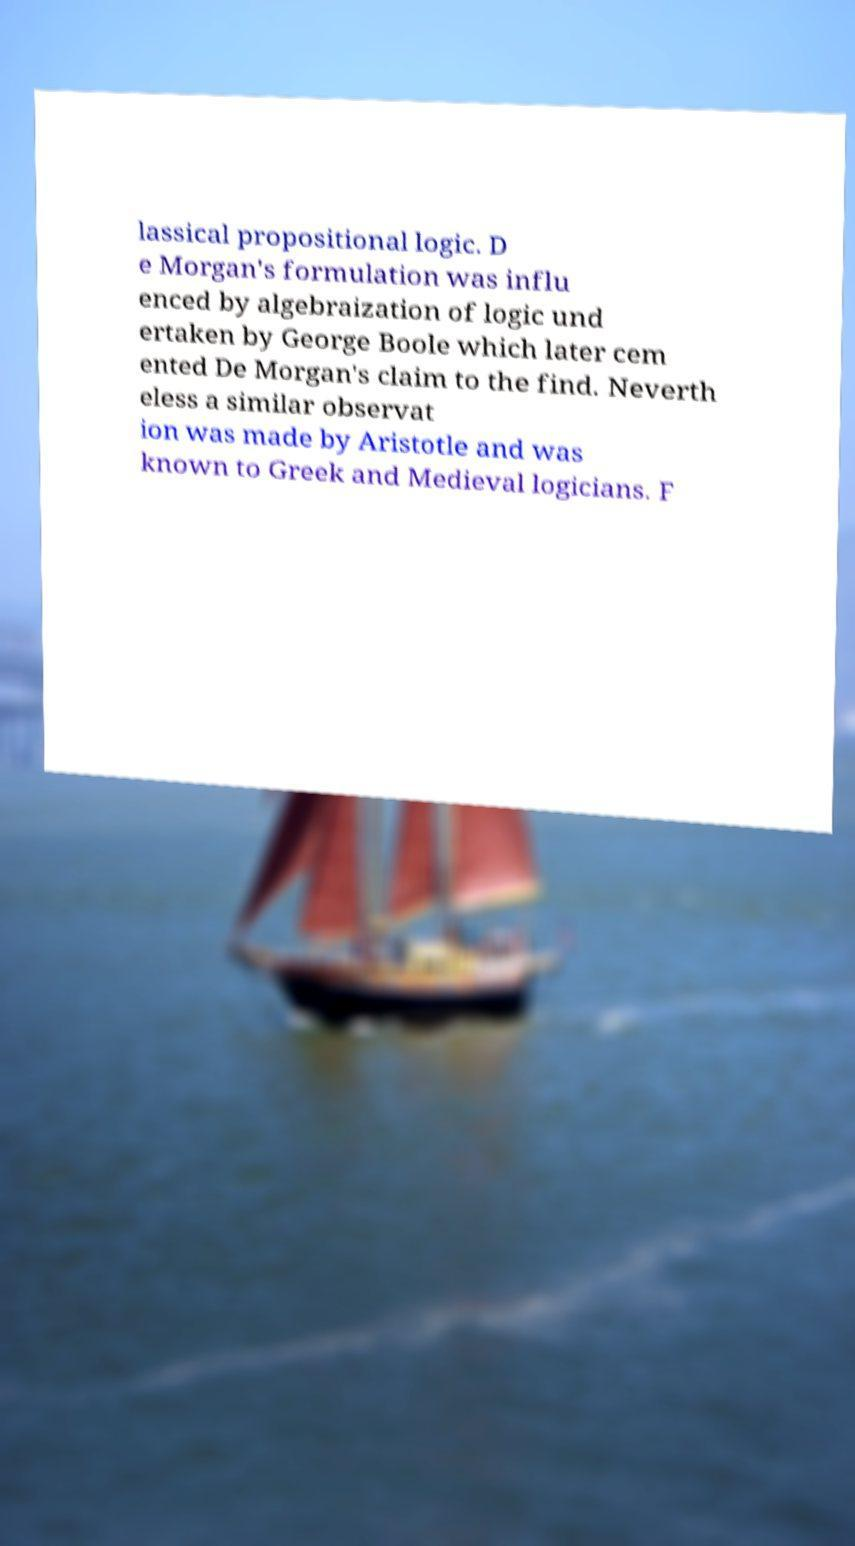What messages or text are displayed in this image? I need them in a readable, typed format. lassical propositional logic. D e Morgan's formulation was influ enced by algebraization of logic und ertaken by George Boole which later cem ented De Morgan's claim to the find. Neverth eless a similar observat ion was made by Aristotle and was known to Greek and Medieval logicians. F 